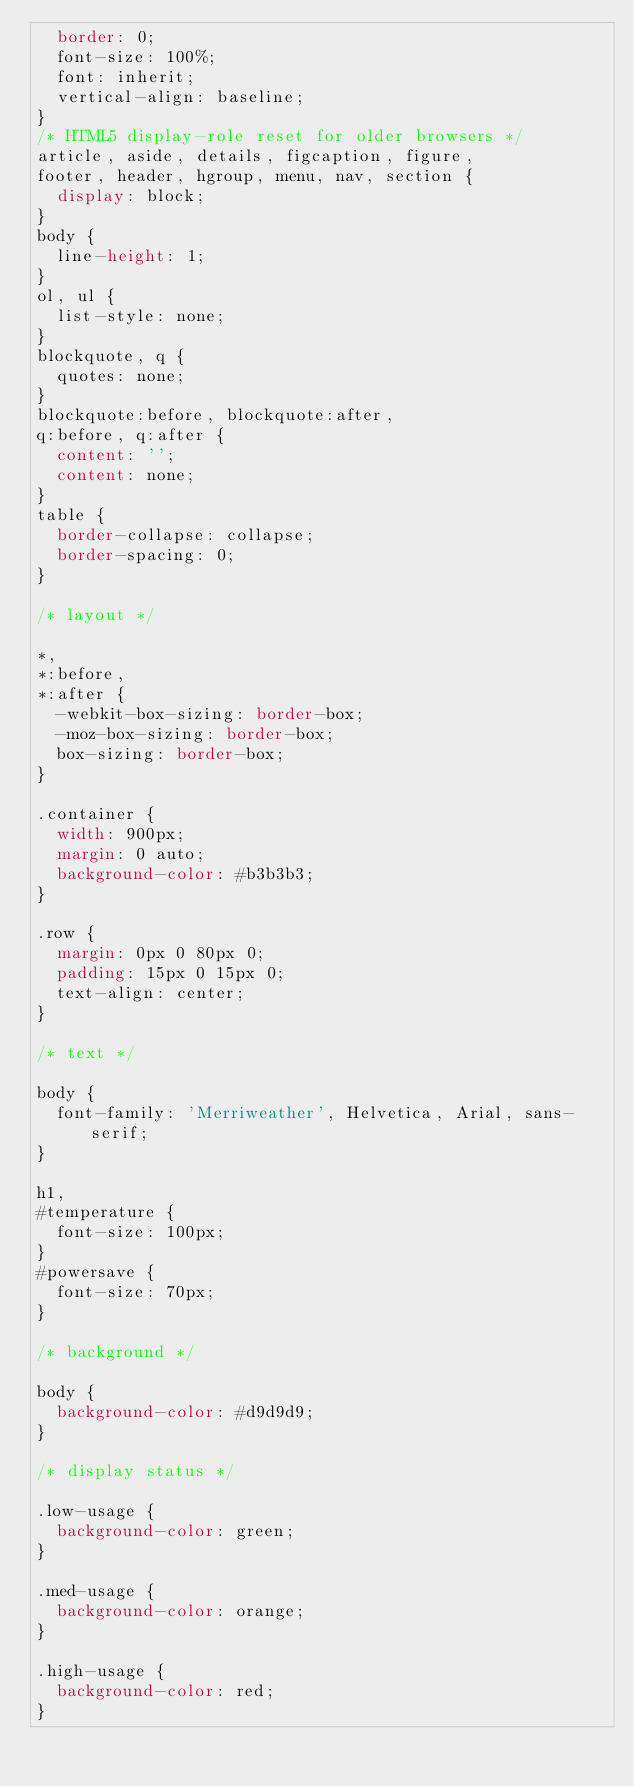Convert code to text. <code><loc_0><loc_0><loc_500><loc_500><_CSS_>	border: 0;
	font-size: 100%;
	font: inherit;
	vertical-align: baseline;
}
/* HTML5 display-role reset for older browsers */
article, aside, details, figcaption, figure, 
footer, header, hgroup, menu, nav, section {
	display: block;
}
body {
	line-height: 1;
}
ol, ul {
	list-style: none;
}
blockquote, q {
	quotes: none;
}
blockquote:before, blockquote:after,
q:before, q:after {
	content: '';
	content: none;
}
table {
	border-collapse: collapse;
	border-spacing: 0;
}

/* layout */

*,
*:before,
*:after {
	-webkit-box-sizing: border-box;
	-moz-box-sizing: border-box;
	box-sizing: border-box;
}

.container {
	width: 900px;
	margin: 0 auto;
	background-color: #b3b3b3;
}

.row {
	margin: 0px 0 80px 0;
	padding: 15px 0 15px 0;
	text-align: center;
}

/* text */

body {
	font-family: 'Merriweather', Helvetica, Arial, sans-serif;
}

h1,
#temperature {
	font-size: 100px;
}
#powersave {
	font-size: 70px;
}

/* background */

body {
	background-color: #d9d9d9;
}

/* display status */

.low-usage {
	background-color: green;
}

.med-usage {
	background-color: orange;
}

.high-usage {
	background-color: red;
}</code> 